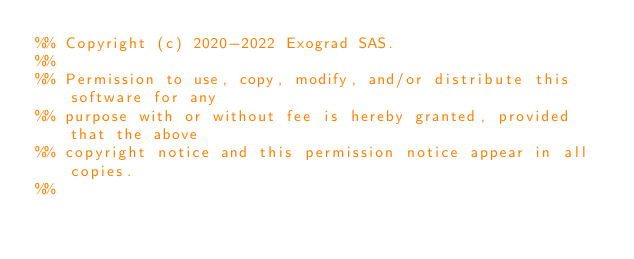Convert code to text. <code><loc_0><loc_0><loc_500><loc_500><_Erlang_>%% Copyright (c) 2020-2022 Exograd SAS.
%%
%% Permission to use, copy, modify, and/or distribute this software for any
%% purpose with or without fee is hereby granted, provided that the above
%% copyright notice and this permission notice appear in all copies.
%%</code> 